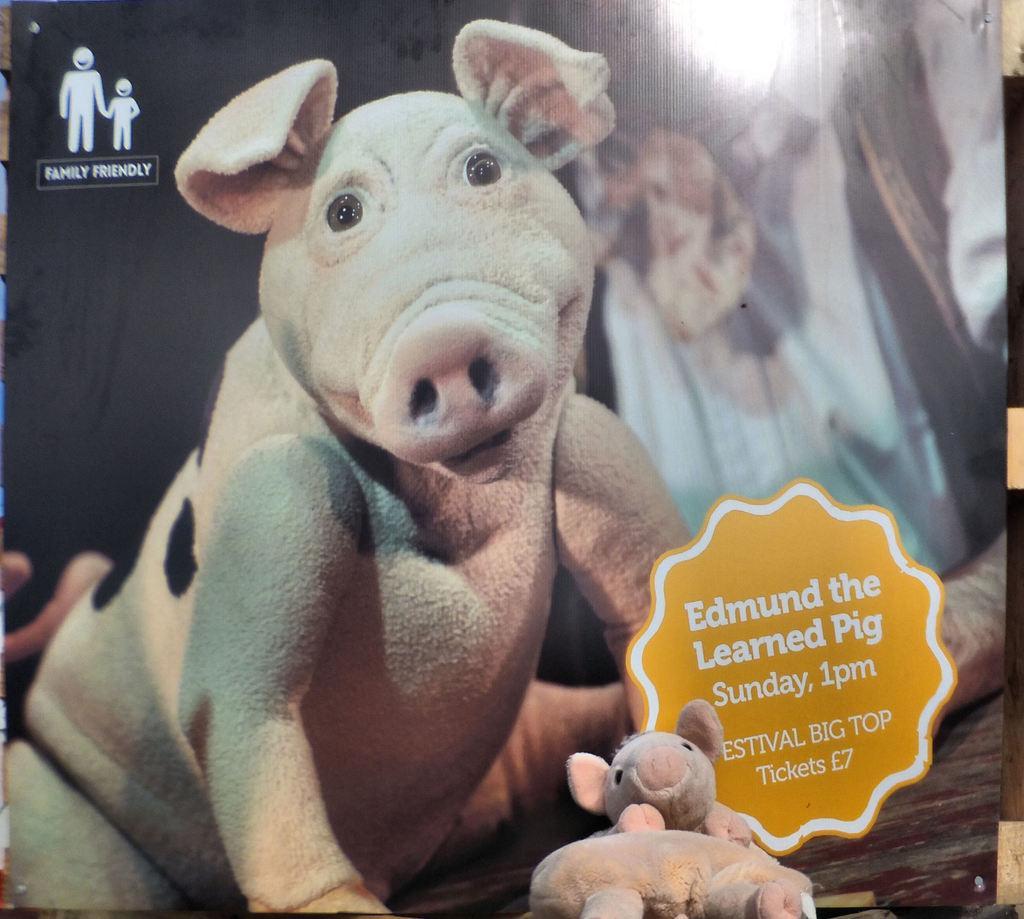How would you summarize this image in a sentence or two? In this picture we can see a poster, toys and in this poster we can see an animal, some text. 